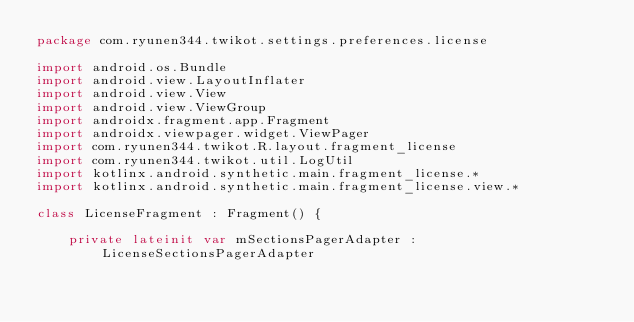Convert code to text. <code><loc_0><loc_0><loc_500><loc_500><_Kotlin_>package com.ryunen344.twikot.settings.preferences.license

import android.os.Bundle
import android.view.LayoutInflater
import android.view.View
import android.view.ViewGroup
import androidx.fragment.app.Fragment
import androidx.viewpager.widget.ViewPager
import com.ryunen344.twikot.R.layout.fragment_license
import com.ryunen344.twikot.util.LogUtil
import kotlinx.android.synthetic.main.fragment_license.*
import kotlinx.android.synthetic.main.fragment_license.view.*

class LicenseFragment : Fragment() {

    private lateinit var mSectionsPagerAdapter : LicenseSectionsPagerAdapter
</code> 